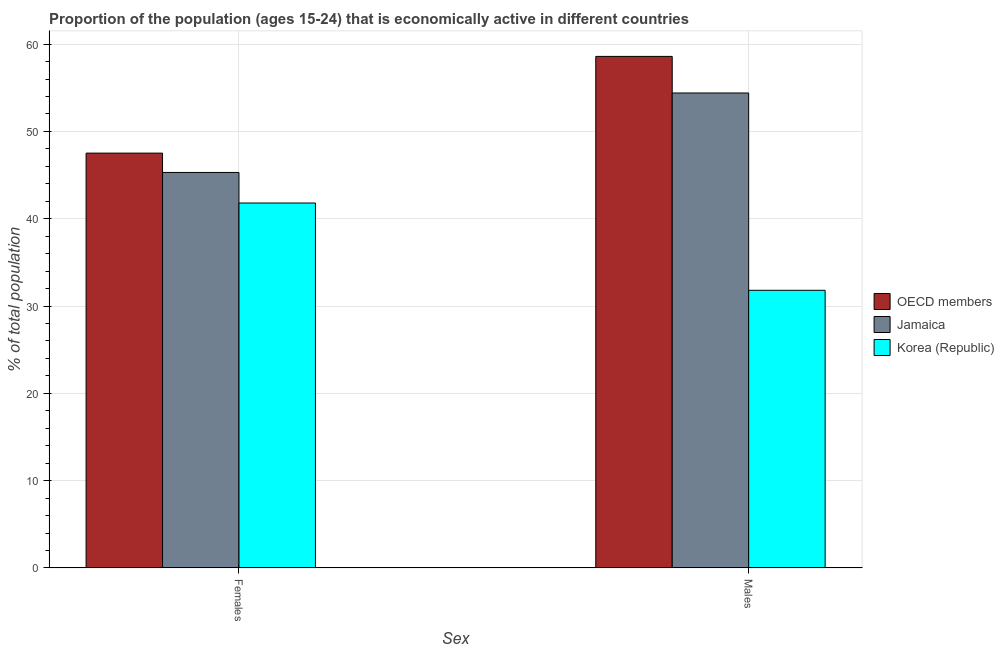Are the number of bars per tick equal to the number of legend labels?
Your answer should be compact. Yes. Are the number of bars on each tick of the X-axis equal?
Provide a short and direct response. Yes. How many bars are there on the 1st tick from the left?
Offer a terse response. 3. How many bars are there on the 1st tick from the right?
Provide a succinct answer. 3. What is the label of the 1st group of bars from the left?
Make the answer very short. Females. What is the percentage of economically active female population in Jamaica?
Keep it short and to the point. 45.3. Across all countries, what is the maximum percentage of economically active female population?
Ensure brevity in your answer.  47.51. Across all countries, what is the minimum percentage of economically active female population?
Offer a very short reply. 41.8. In which country was the percentage of economically active male population maximum?
Give a very brief answer. OECD members. What is the total percentage of economically active male population in the graph?
Make the answer very short. 144.79. What is the difference between the percentage of economically active male population in Jamaica and that in OECD members?
Your answer should be compact. -4.19. What is the difference between the percentage of economically active female population in OECD members and the percentage of economically active male population in Korea (Republic)?
Your response must be concise. 15.71. What is the average percentage of economically active male population per country?
Make the answer very short. 48.26. What is the difference between the percentage of economically active male population and percentage of economically active female population in OECD members?
Provide a short and direct response. 11.08. What is the ratio of the percentage of economically active female population in Jamaica to that in OECD members?
Provide a short and direct response. 0.95. Is the percentage of economically active female population in OECD members less than that in Jamaica?
Make the answer very short. No. What does the 3rd bar from the right in Males represents?
Provide a succinct answer. OECD members. Are all the bars in the graph horizontal?
Provide a short and direct response. No. What is the difference between two consecutive major ticks on the Y-axis?
Your answer should be compact. 10. Are the values on the major ticks of Y-axis written in scientific E-notation?
Offer a terse response. No. Does the graph contain any zero values?
Make the answer very short. No. Where does the legend appear in the graph?
Provide a succinct answer. Center right. How are the legend labels stacked?
Your response must be concise. Vertical. What is the title of the graph?
Your answer should be very brief. Proportion of the population (ages 15-24) that is economically active in different countries. What is the label or title of the X-axis?
Provide a short and direct response. Sex. What is the label or title of the Y-axis?
Your response must be concise. % of total population. What is the % of total population in OECD members in Females?
Offer a very short reply. 47.51. What is the % of total population in Jamaica in Females?
Ensure brevity in your answer.  45.3. What is the % of total population in Korea (Republic) in Females?
Make the answer very short. 41.8. What is the % of total population of OECD members in Males?
Your response must be concise. 58.59. What is the % of total population of Jamaica in Males?
Provide a succinct answer. 54.4. What is the % of total population of Korea (Republic) in Males?
Offer a terse response. 31.8. Across all Sex, what is the maximum % of total population in OECD members?
Your response must be concise. 58.59. Across all Sex, what is the maximum % of total population in Jamaica?
Provide a succinct answer. 54.4. Across all Sex, what is the maximum % of total population of Korea (Republic)?
Provide a succinct answer. 41.8. Across all Sex, what is the minimum % of total population in OECD members?
Offer a very short reply. 47.51. Across all Sex, what is the minimum % of total population of Jamaica?
Your response must be concise. 45.3. Across all Sex, what is the minimum % of total population in Korea (Republic)?
Keep it short and to the point. 31.8. What is the total % of total population of OECD members in the graph?
Your answer should be very brief. 106.11. What is the total % of total population of Jamaica in the graph?
Offer a very short reply. 99.7. What is the total % of total population in Korea (Republic) in the graph?
Your answer should be very brief. 73.6. What is the difference between the % of total population of OECD members in Females and that in Males?
Keep it short and to the point. -11.08. What is the difference between the % of total population of Korea (Republic) in Females and that in Males?
Your answer should be compact. 10. What is the difference between the % of total population of OECD members in Females and the % of total population of Jamaica in Males?
Make the answer very short. -6.89. What is the difference between the % of total population of OECD members in Females and the % of total population of Korea (Republic) in Males?
Give a very brief answer. 15.71. What is the difference between the % of total population in Jamaica in Females and the % of total population in Korea (Republic) in Males?
Provide a succinct answer. 13.5. What is the average % of total population in OECD members per Sex?
Keep it short and to the point. 53.05. What is the average % of total population in Jamaica per Sex?
Ensure brevity in your answer.  49.85. What is the average % of total population in Korea (Republic) per Sex?
Make the answer very short. 36.8. What is the difference between the % of total population in OECD members and % of total population in Jamaica in Females?
Ensure brevity in your answer.  2.21. What is the difference between the % of total population of OECD members and % of total population of Korea (Republic) in Females?
Give a very brief answer. 5.71. What is the difference between the % of total population of Jamaica and % of total population of Korea (Republic) in Females?
Keep it short and to the point. 3.5. What is the difference between the % of total population in OECD members and % of total population in Jamaica in Males?
Your answer should be very brief. 4.19. What is the difference between the % of total population in OECD members and % of total population in Korea (Republic) in Males?
Keep it short and to the point. 26.79. What is the difference between the % of total population of Jamaica and % of total population of Korea (Republic) in Males?
Keep it short and to the point. 22.6. What is the ratio of the % of total population of OECD members in Females to that in Males?
Your answer should be very brief. 0.81. What is the ratio of the % of total population of Jamaica in Females to that in Males?
Keep it short and to the point. 0.83. What is the ratio of the % of total population of Korea (Republic) in Females to that in Males?
Your response must be concise. 1.31. What is the difference between the highest and the second highest % of total population of OECD members?
Provide a succinct answer. 11.08. What is the difference between the highest and the lowest % of total population in OECD members?
Give a very brief answer. 11.08. What is the difference between the highest and the lowest % of total population of Jamaica?
Give a very brief answer. 9.1. 